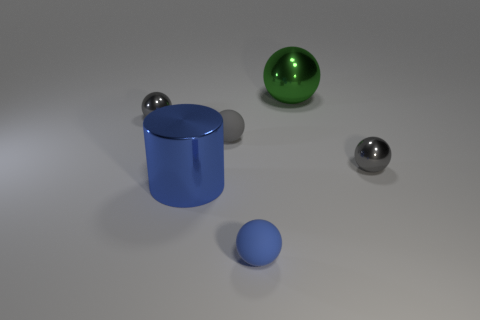There is another matte thing that is the same shape as the blue rubber thing; what size is it?
Offer a terse response. Small. The rubber object that is the same color as the big shiny cylinder is what size?
Provide a short and direct response. Small. Are the big green ball and the large object that is to the left of the green shiny thing made of the same material?
Provide a short and direct response. Yes. What is the color of the big shiny sphere?
Offer a very short reply. Green. There is a cylinder that is the same material as the large ball; what size is it?
Your answer should be compact. Large. How many green shiny spheres are behind the metallic thing behind the metal ball on the left side of the large green metallic object?
Provide a short and direct response. 0. There is a cylinder; does it have the same color as the small rubber sphere in front of the large blue cylinder?
Offer a very short reply. Yes. What is the shape of the tiny thing that is the same color as the cylinder?
Give a very brief answer. Sphere. The sphere in front of the small gray metal sphere in front of the gray metallic thing left of the blue matte thing is made of what material?
Provide a short and direct response. Rubber. There is a thing that is on the right side of the green thing; is it the same shape as the tiny blue rubber object?
Offer a very short reply. Yes. 